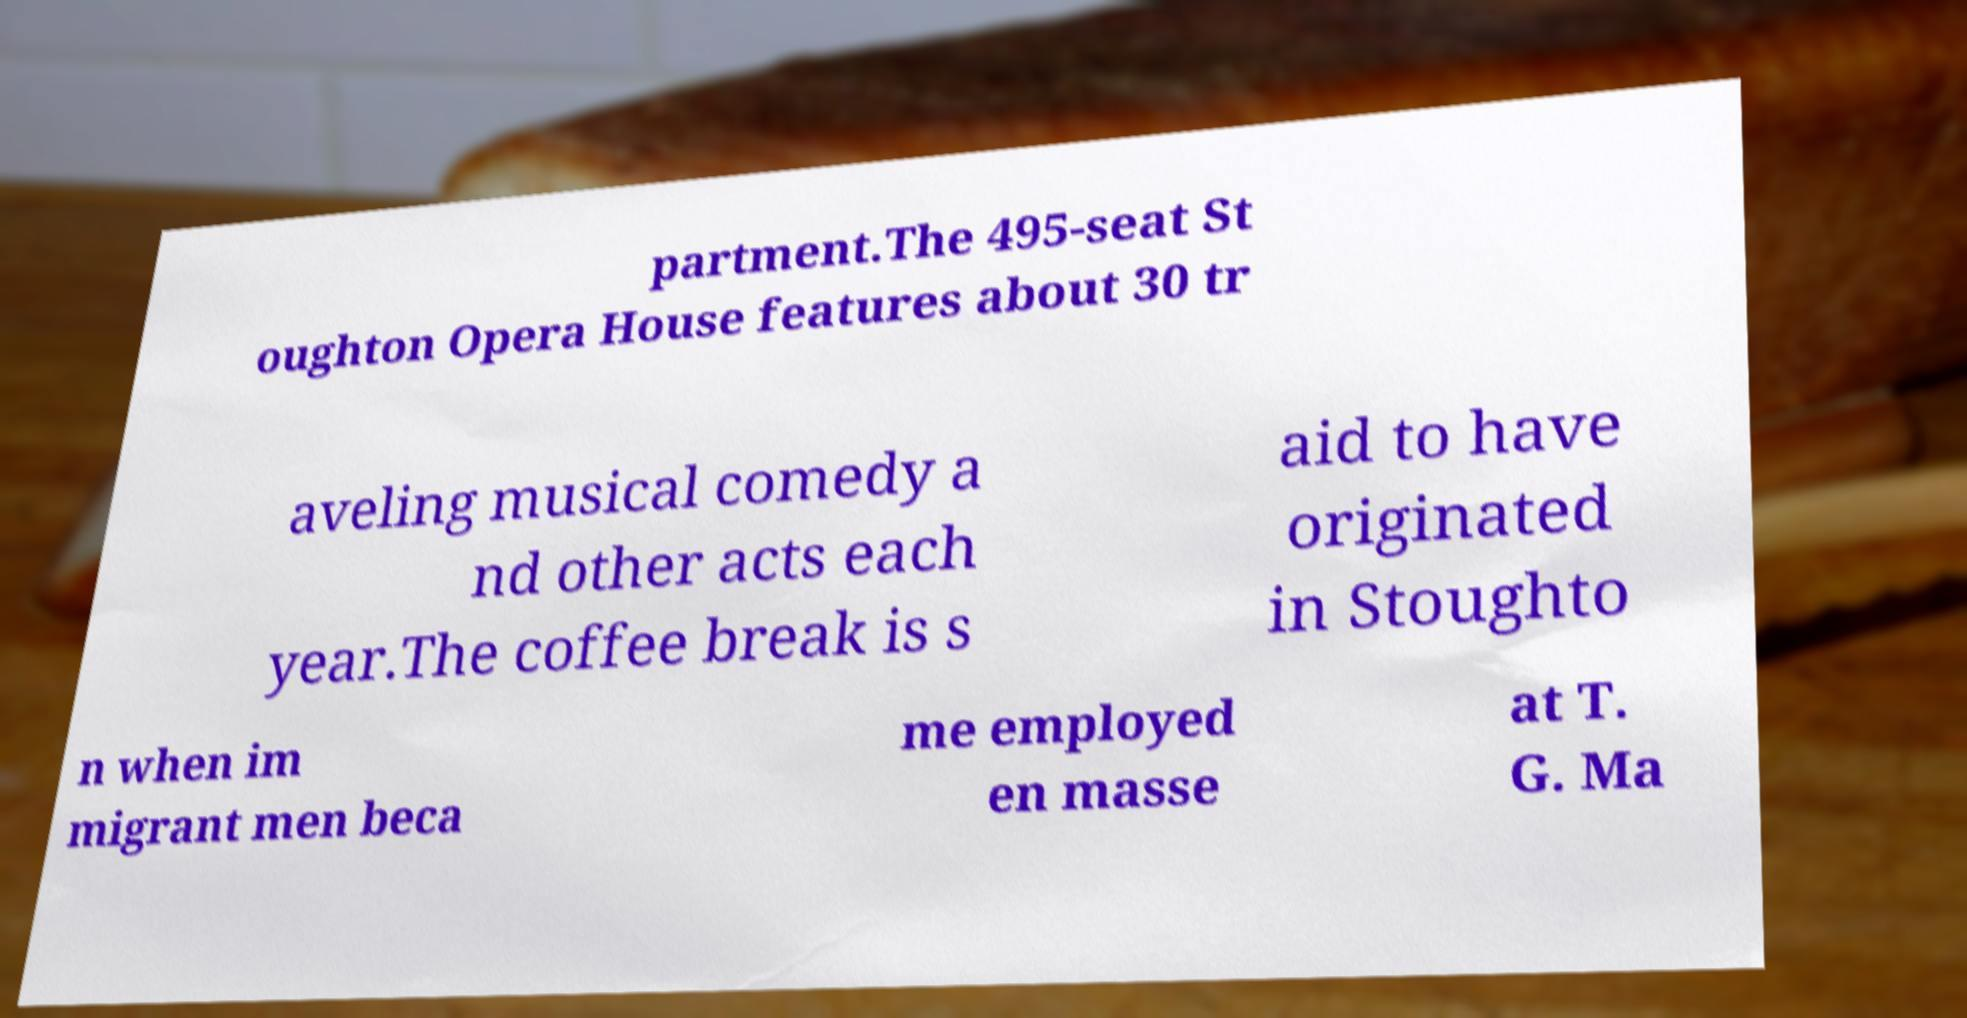I need the written content from this picture converted into text. Can you do that? partment.The 495-seat St oughton Opera House features about 30 tr aveling musical comedy a nd other acts each year.The coffee break is s aid to have originated in Stoughto n when im migrant men beca me employed en masse at T. G. Ma 